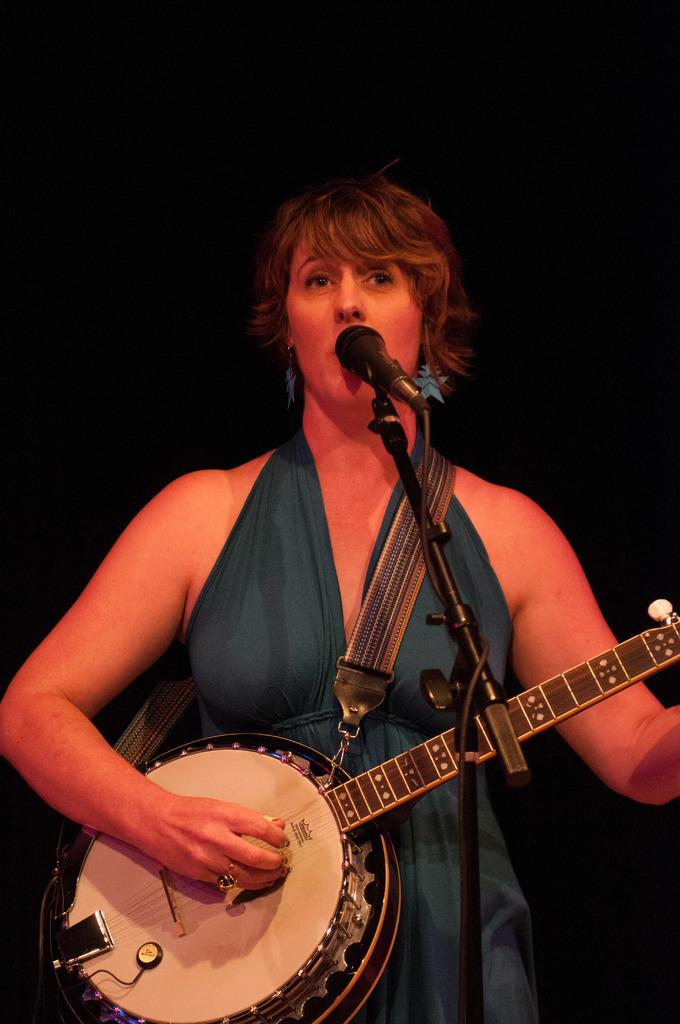Who is the main subject in the image? There is a woman in the image. What is the woman doing in the image? The woman is singing and playing a guitar. What tool is the woman using to amplify her voice? The woman is using a microphone. What color is the thread used to sew the curtain in the image? There is no curtain or thread present in the image; it features a woman singing and playing a guitar. 